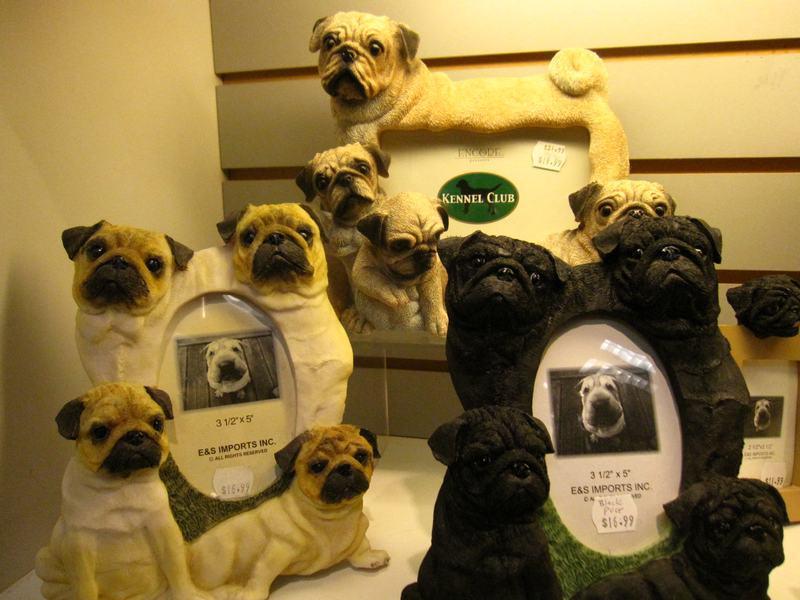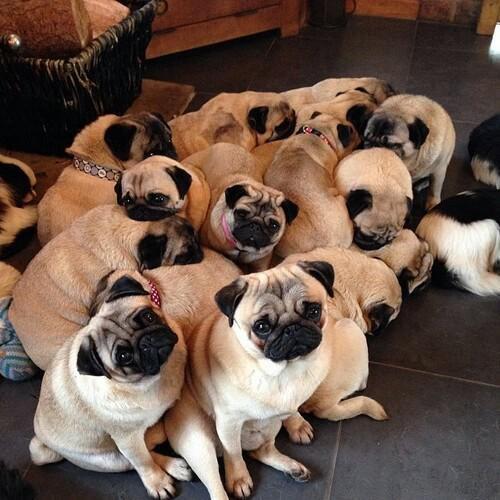The first image is the image on the left, the second image is the image on the right. Examine the images to the left and right. Is the description "there is exactly one dog in the image on the left" accurate? Answer yes or no. No. The first image is the image on the left, the second image is the image on the right. Evaluate the accuracy of this statement regarding the images: "An image shows exactly one living pug that is sitting.". Is it true? Answer yes or no. No. 